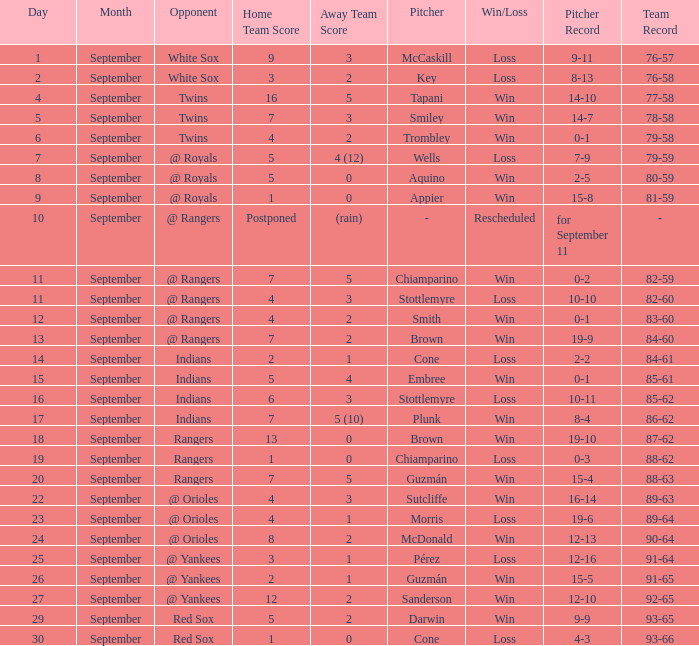What is the score from September 15 that has the Indians as the opponent? 5 - 4. 